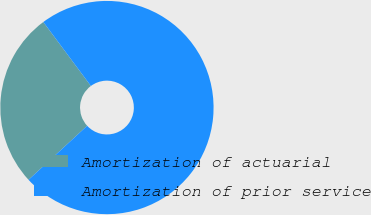Convert chart to OTSL. <chart><loc_0><loc_0><loc_500><loc_500><pie_chart><fcel>Amortization of actuarial<fcel>Amortization of prior service<nl><fcel>26.67%<fcel>73.33%<nl></chart> 